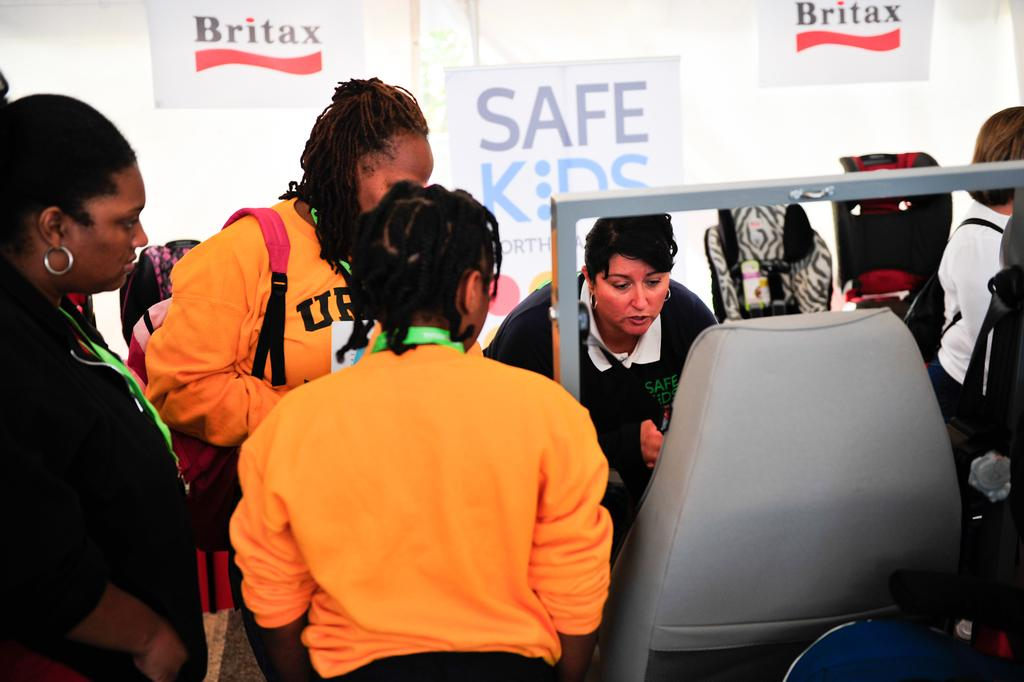What type of furniture is present in the image? There is a chair in the image. Can you describe the people in the image? There are people in the image. What can be seen in the background of the image? There are banners in the background of the image. What force is being applied to the chair by the people in the image? There is no information about any force being applied to the chair by the people in the image. How many feet are visible in the image? There is no information about any feet being visible in the image. 